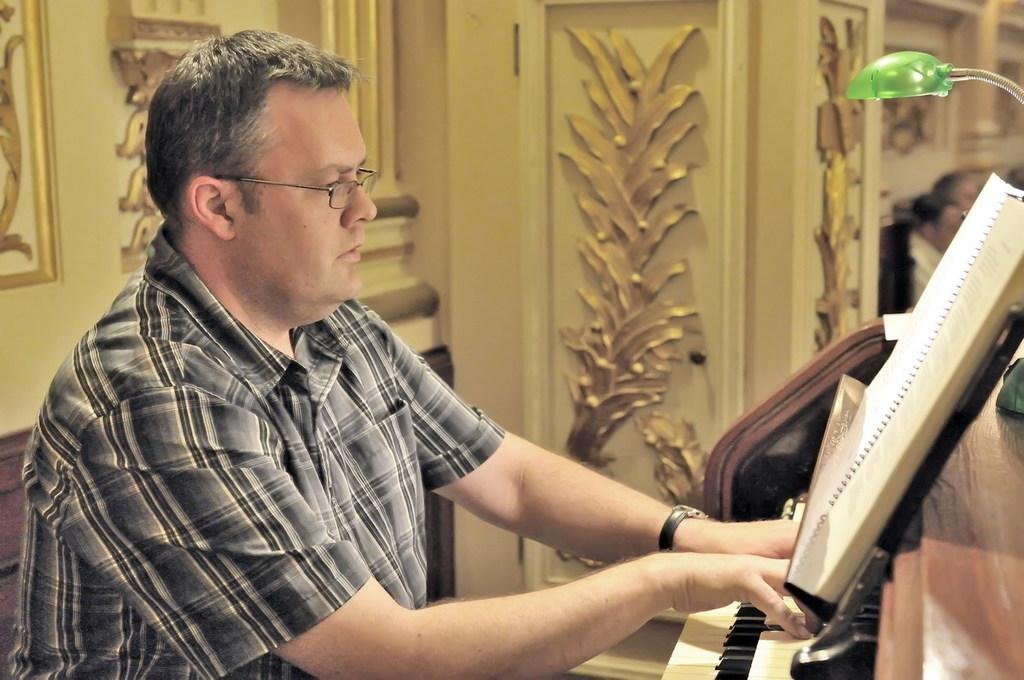What is the person in the image doing? The person is playing the piano. What object is in front of the person? There is a book in front of the person. Can you describe the person's activity in the image? The person is sitting and playing the piano. What type of rice is being cooked in the image? There is no rice present in the image; it features a person playing the piano with a book in front of them. 